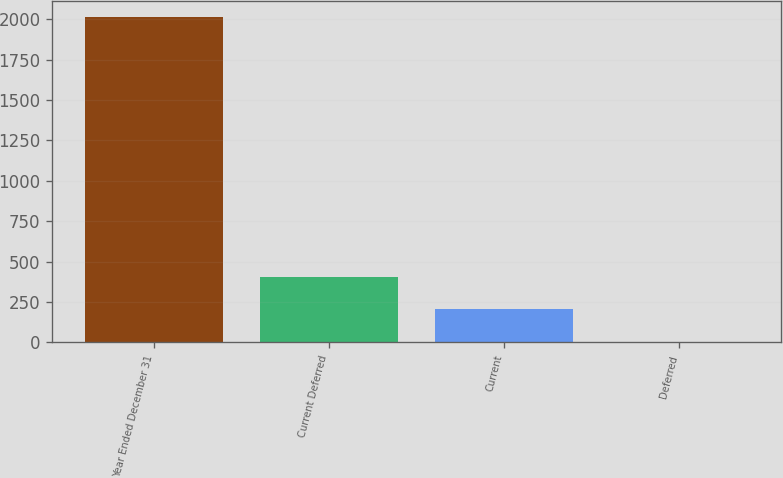Convert chart to OTSL. <chart><loc_0><loc_0><loc_500><loc_500><bar_chart><fcel>Year Ended December 31<fcel>Current Deferred<fcel>Current<fcel>Deferred<nl><fcel>2015<fcel>407<fcel>206<fcel>5<nl></chart> 